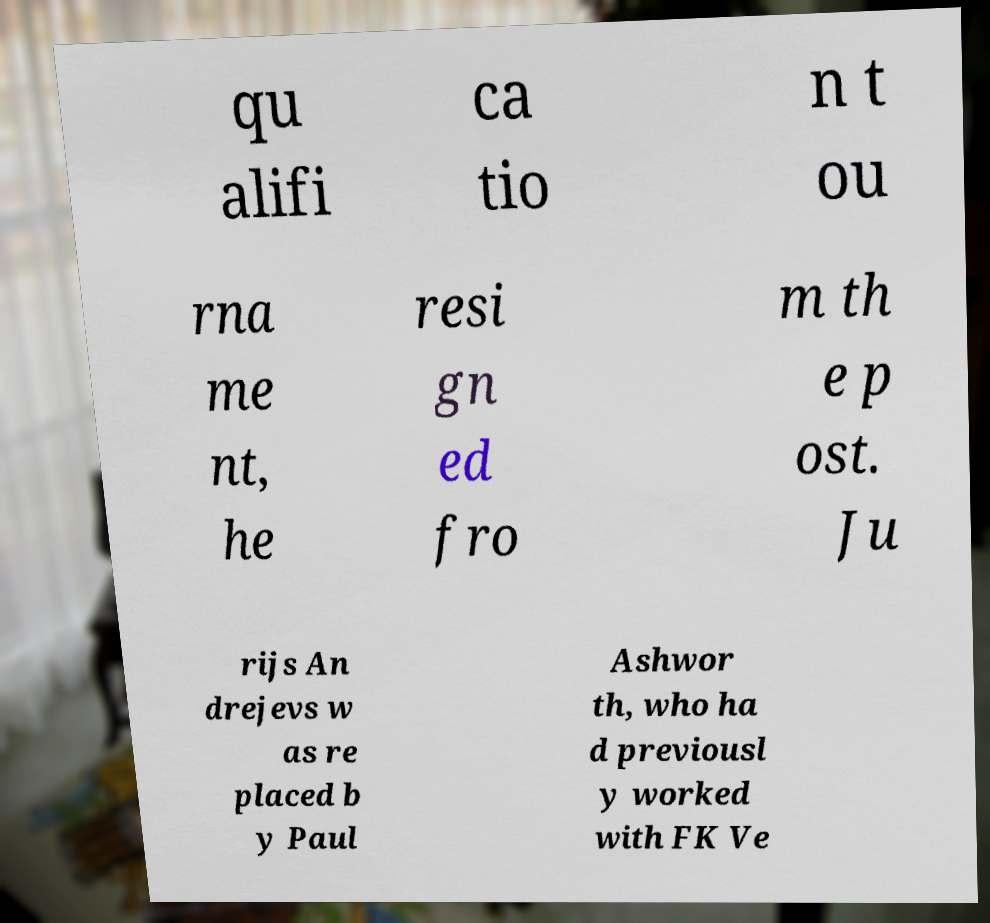There's text embedded in this image that I need extracted. Can you transcribe it verbatim? qu alifi ca tio n t ou rna me nt, he resi gn ed fro m th e p ost. Ju rijs An drejevs w as re placed b y Paul Ashwor th, who ha d previousl y worked with FK Ve 